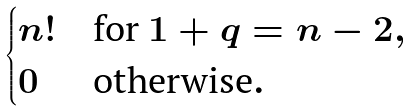<formula> <loc_0><loc_0><loc_500><loc_500>\begin{cases} n ! & \text {for $1+q = n-2$} , \\ 0 & \text {otherwise} . \end{cases}</formula> 